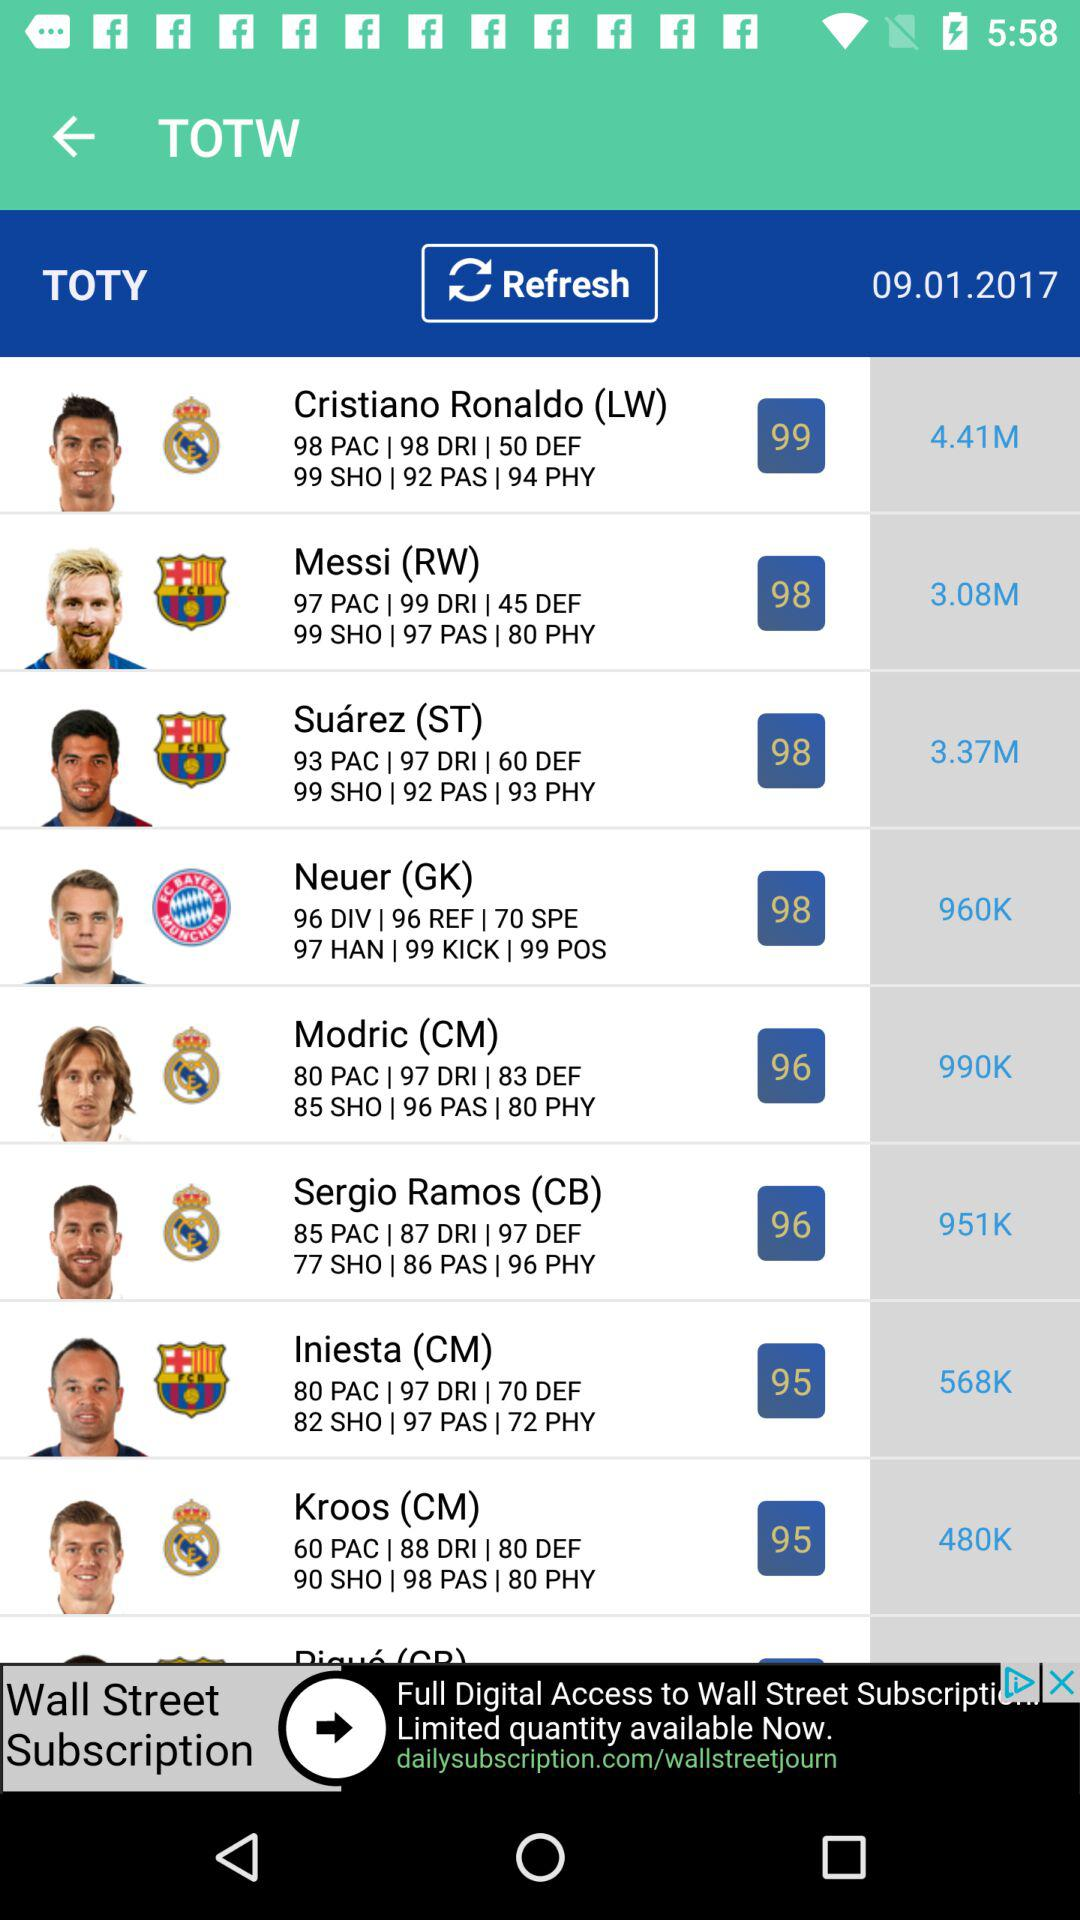What is the PAC for Messi? The PAC for Messi is 97. 